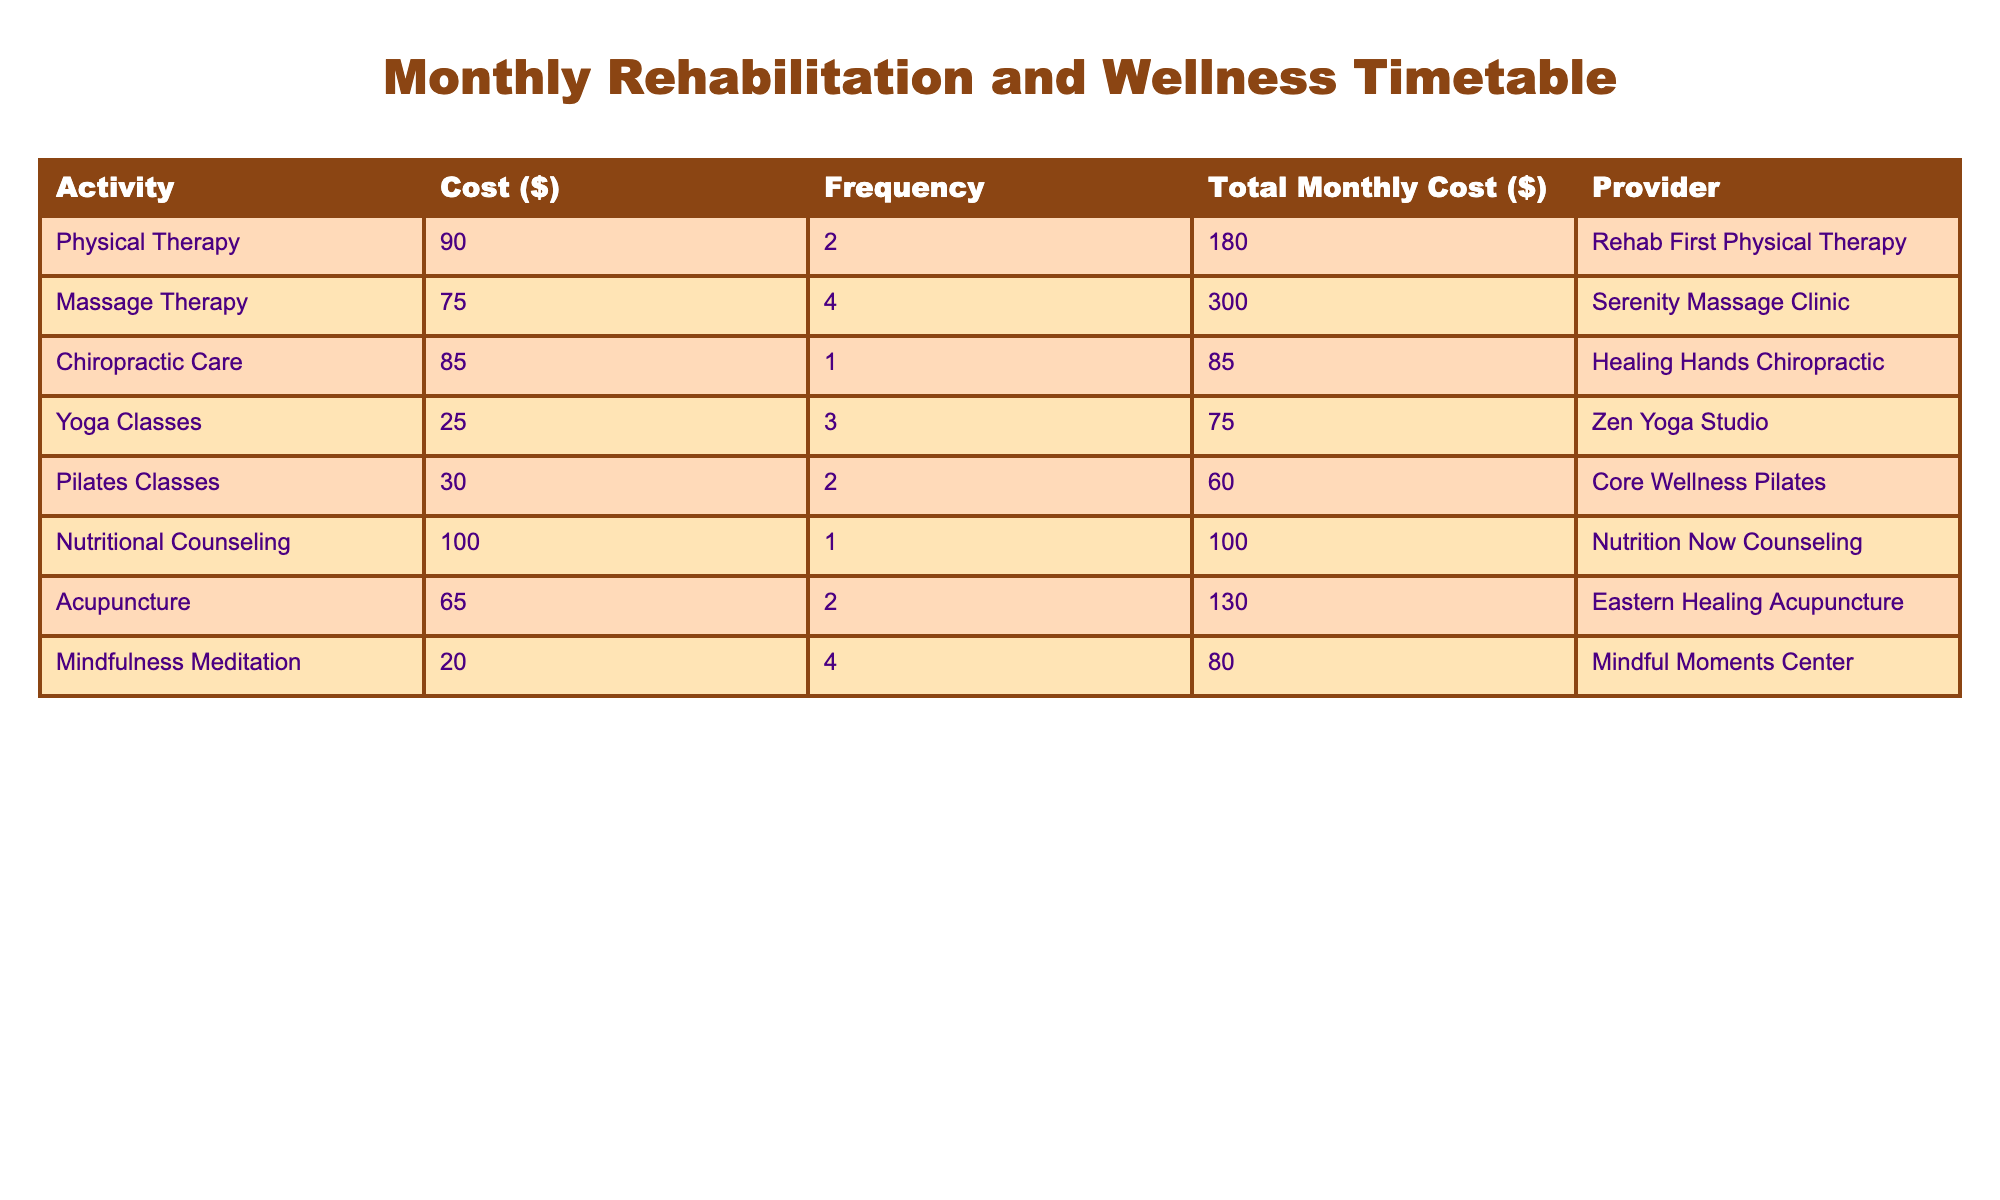What is the total cost of Physical Therapy in a month? The table shows that the cost of each Physical Therapy session is $90, and the frequency is 2 sessions. Therefore, the total cost is calculated by multiplying the cost per session by the frequency: 90 * 2 = 180.
Answer: 180 What is the most expensive activity on the list? By examining the total monthly costs for each activity in the table, Massage Therapy has the highest total monthly cost of $300.
Answer: Massage Therapy How much does Nutritional Counseling cost compared to Chiropractic Care? The total monthly cost of Nutritional Counseling is $100 while Chiropractic Care costs $85. To find the difference, we subtract the cost of Chiropractic Care from Nutritional Counseling: 100 - 85 = 15.
Answer: 15 Are there more wellness activities that have a total monthly cost below $100 than those above? From the table, we can list the activities with costs below $100: Chiropractic Care ($85), Pilates Classes ($60), and Yoga Classes ($75), totaling 3 activities. The activities above $100 are Massage Therapy ($300), Acupuncture ($130), and Nutritional Counseling ($100), totaling 3 activities as well. Since both counts are equal, the answer is false.
Answer: False What is the average total monthly cost of all activities listed? To find the average total monthly cost, we first sum all the total monthly costs: 180 + 300 + 85 + 75 + 60 + 100 + 130 + 80 = 1,010. There are 8 activities, thus the average is 1,010 divided by 8 which is approximately 126.25.
Answer: 126.25 What percentage of the total monthly cost is spent on Massage Therapy? First, we find the total monthly cost for all activities which is $1,010. Massage Therapy costs $300. The percentage is calculated by (300 / 1010) * 100 which equals about 29.70%.
Answer: 29.70% 